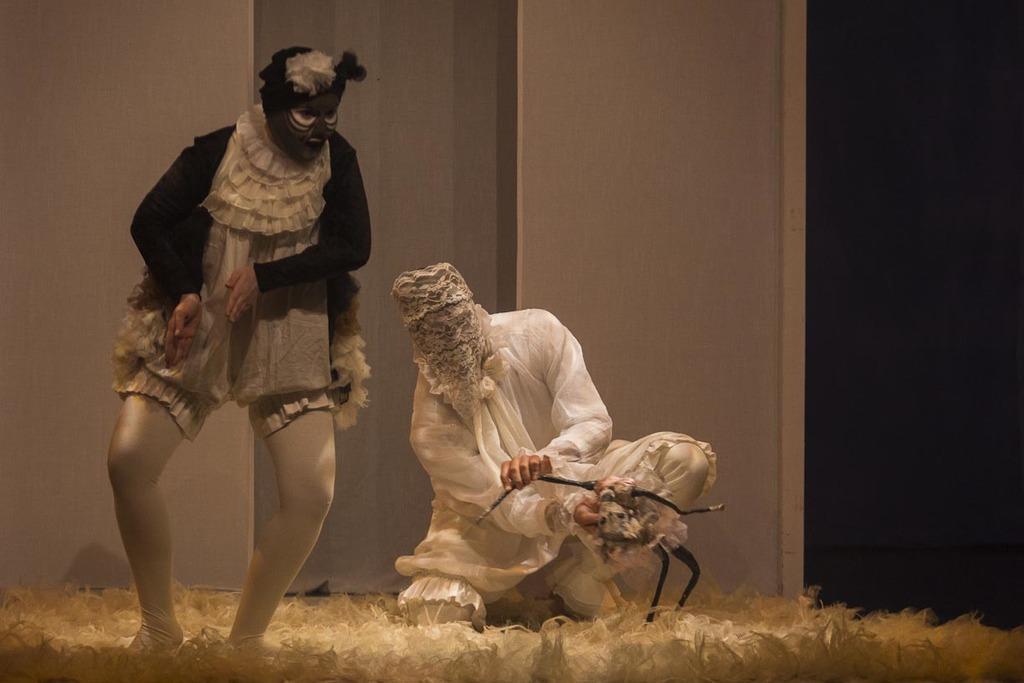Can you describe this image briefly? In this image we can see two people wearing mask. In the background of the image there is wall. At the bottom of the image there is white color surface. 